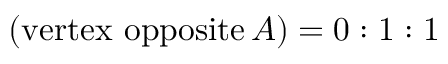Convert formula to latex. <formula><loc_0><loc_0><loc_500><loc_500>\ \left ( { v e r t e x o p p o s i t e } \, A \right ) = 0 \colon 1 \colon 1</formula> 